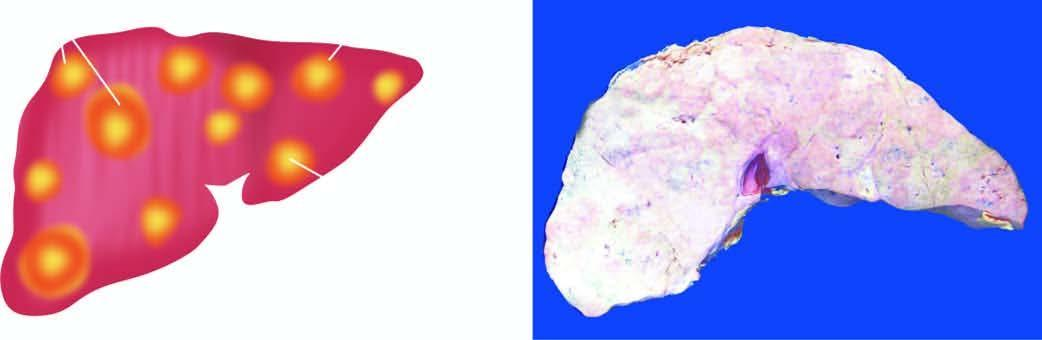do common stains include multiple, variable-sized, nodular masses, often under the capsule, producing umbilication on the surface?
Answer the question using a single word or phrase. No 